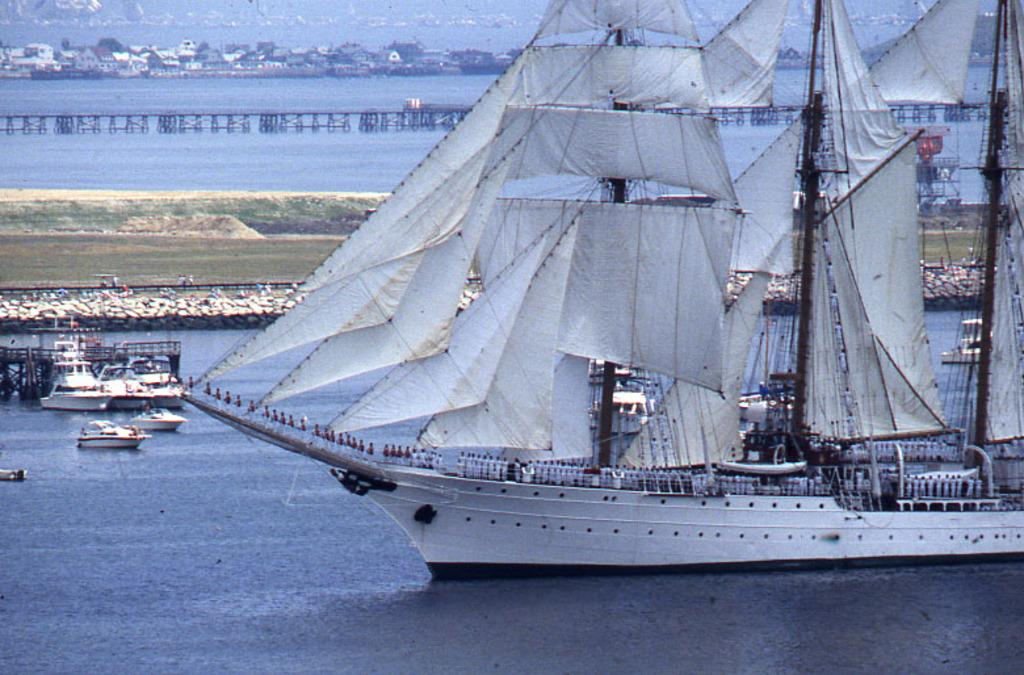What type of vehicle is in the image? There is a ship in the image. Are there any other similar vehicles in the image? Yes, there are boats in the image. Where are the ship and boats located? The ship and boats are on the water. What can be seen in the background of the image? There is a bridge, houses, and trees in the background of the image. What organization is responsible for the competition taking place in the image? There is no competition present in the image, so it is not possible to determine which organization might be responsible. 